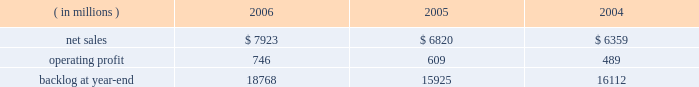Operating profit for the segment increased by 15% ( 15 % ) in 2005 compared to 2004 .
Operating profit increased by $ 80 million at m&fc mainly due to improved performance on fire control and air defense programs .
Performance on surface systems programs contributed to an increase in operating profit of $ 50 million at ms2 .
Pt&ts operating profit increased $ 10 million primarily due to improved performance on simulation and training programs .
The increase in backlog during 2006 over 2005 resulted primarily from increased orders on certain platform integration programs in pt&ts .
Space systems space systems 2019 operating results included the following : ( in millions ) 2006 2005 2004 .
Net sales for space systems increased by 16% ( 16 % ) in 2006 compared to 2005 .
During the year , sales growth in satellites and strategic & defensive missile systems ( s&dms ) offset declines in space transportation .
The $ 1.1 billion growth in satellites sales was mainly due to higher volume on both government and commercial satellite programs .
There were five commercial satellite deliveries in 2006 compared to no deliveries in 2005 .
Higher volume in both fleet ballistic missile and missile defense programs accounted for the $ 114 million sales increase at s&dms .
In space transportation , sales declined $ 102 million primarily due to lower volume in government space transportation activities on the titan and external tank programs .
Increased sales on the atlas evolved expendable launch vehicle launch capabilities ( elc ) contract partially offset the lower government space transportation sales .
Net sales for space systems increased by 7% ( 7 % ) in 2005 compared to 2004 .
During the year , sales growth in satellites and s&dms offset declines in space transportation .
The $ 410 million increase in satellites sales was due to higher volume on government satellite programs that more than offset declines in commercial satellite activities .
There were no commercial satellite deliveries in 2005 , compared to four in 2004 .
Increased sales of $ 235 million in s&dms were attributable to the fleet ballistic missile and missile defense programs .
The $ 180 million decrease in space transportation 2019s sales was mainly due to having three atlas launches in 2005 compared to six in 2004 .
Operating profit for the segment increased 22% ( 22 % ) in 2006 compared to 2005 .
Operating profit increased in satellites , space transportation and s&dms .
The $ 72 million growth in satellites operating profit was primarily driven by the volume and performance on government satellite programs and commercial satellite deliveries .
In space transportation , the $ 39 million growth in operating profit was attributable to improved performance on the atlas program resulting from risk reduction activities , including the first quarter definitization of the elc contract .
In s&dms , the $ 26 million increase in operating profit was due to higher volume and improved performance on both the fleet ballistic missile and missile defense programs .
Operating profit for the segment increased 25% ( 25 % ) in 2005 compared to 2004 .
Operating profit increased in space transportation , s&dms and satellites .
In space transportation , the $ 60 million increase in operating profit was primarily attributable to improved performance on the atlas vehicle program .
Satellites 2019 operating profit increased $ 35 million due to the higher volume and improved performance on government satellite programs , which more than offset the decreased operating profit due to the decline in commercial satellite deliveries .
The $ 20 million increase in s&dms was attributable to higher volume on fleet ballistic missile and missile defense programs .
In december 2006 , we completed a transaction with boeing to form ula , a joint venture which combines the production , engineering , test and launch operations associated with u.s .
Government launches of our atlas launch vehicles and boeing 2019s delta launch vehicles ( see related discussion on our 201cspace business 201d under 201cindustry considerations 201d ) .
We are accounting for our investment in ula under the equity method of accounting .
As a result , our share of the net earnings or losses of ula are included in other income and expenses , and we will no longer recognize sales related to launch vehicle services provided to the u.s .
Government .
In 2006 , we recorded sales to the u.s .
Government for atlas launch services totaling approximately $ 600 million .
We have retained the right to market commercial atlas launch services .
We contributed assets to ula , and ula assumed liabilities related to our atlas business in exchange for our 50% ( 50 % ) ownership interest .
The net book value of the assets contributed and liabilities assumed was approximately $ 200 million at .
What were average operating profitfor space systems from 2004 to 2006 , in millions? 
Computations: table_average(operating profit, none)
Answer: 614.66667. 